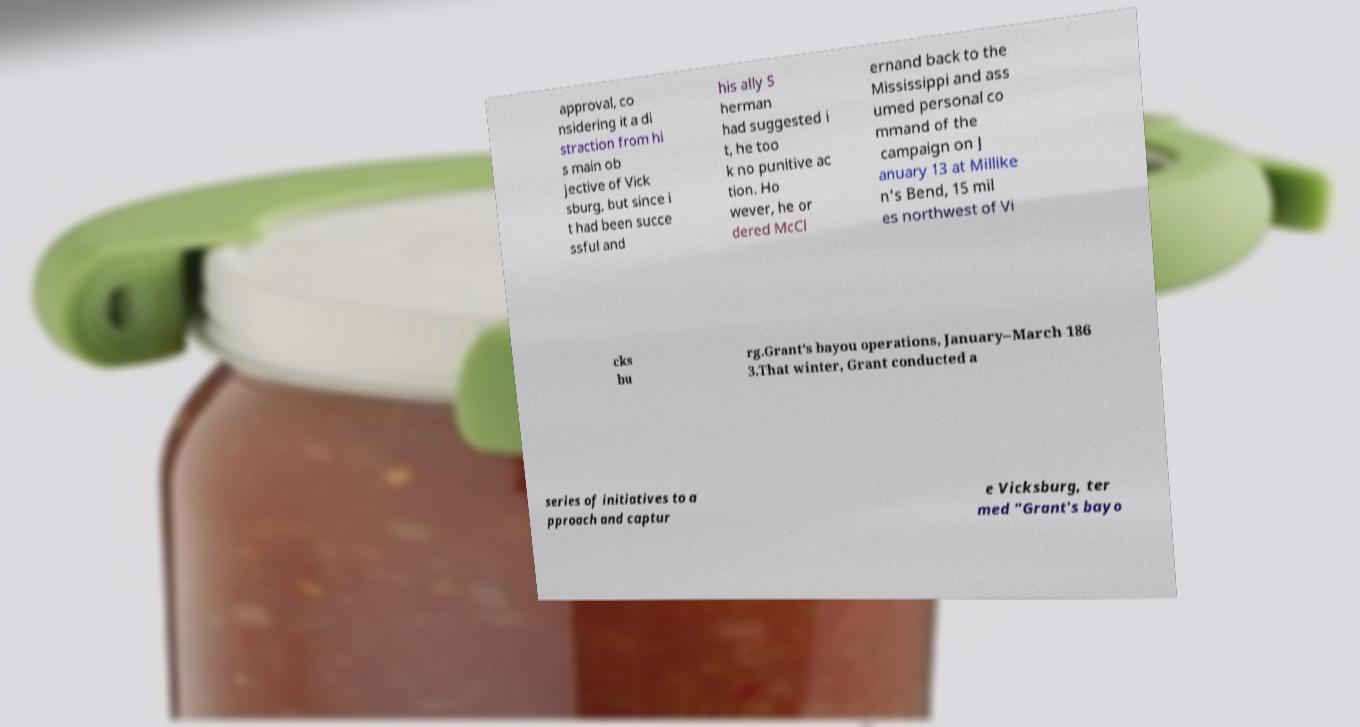Can you accurately transcribe the text from the provided image for me? approval, co nsidering it a di straction from hi s main ob jective of Vick sburg, but since i t had been succe ssful and his ally S herman had suggested i t, he too k no punitive ac tion. Ho wever, he or dered McCl ernand back to the Mississippi and ass umed personal co mmand of the campaign on J anuary 13 at Millike n's Bend, 15 mil es northwest of Vi cks bu rg.Grant's bayou operations, January–March 186 3.That winter, Grant conducted a series of initiatives to a pproach and captur e Vicksburg, ter med "Grant's bayo 